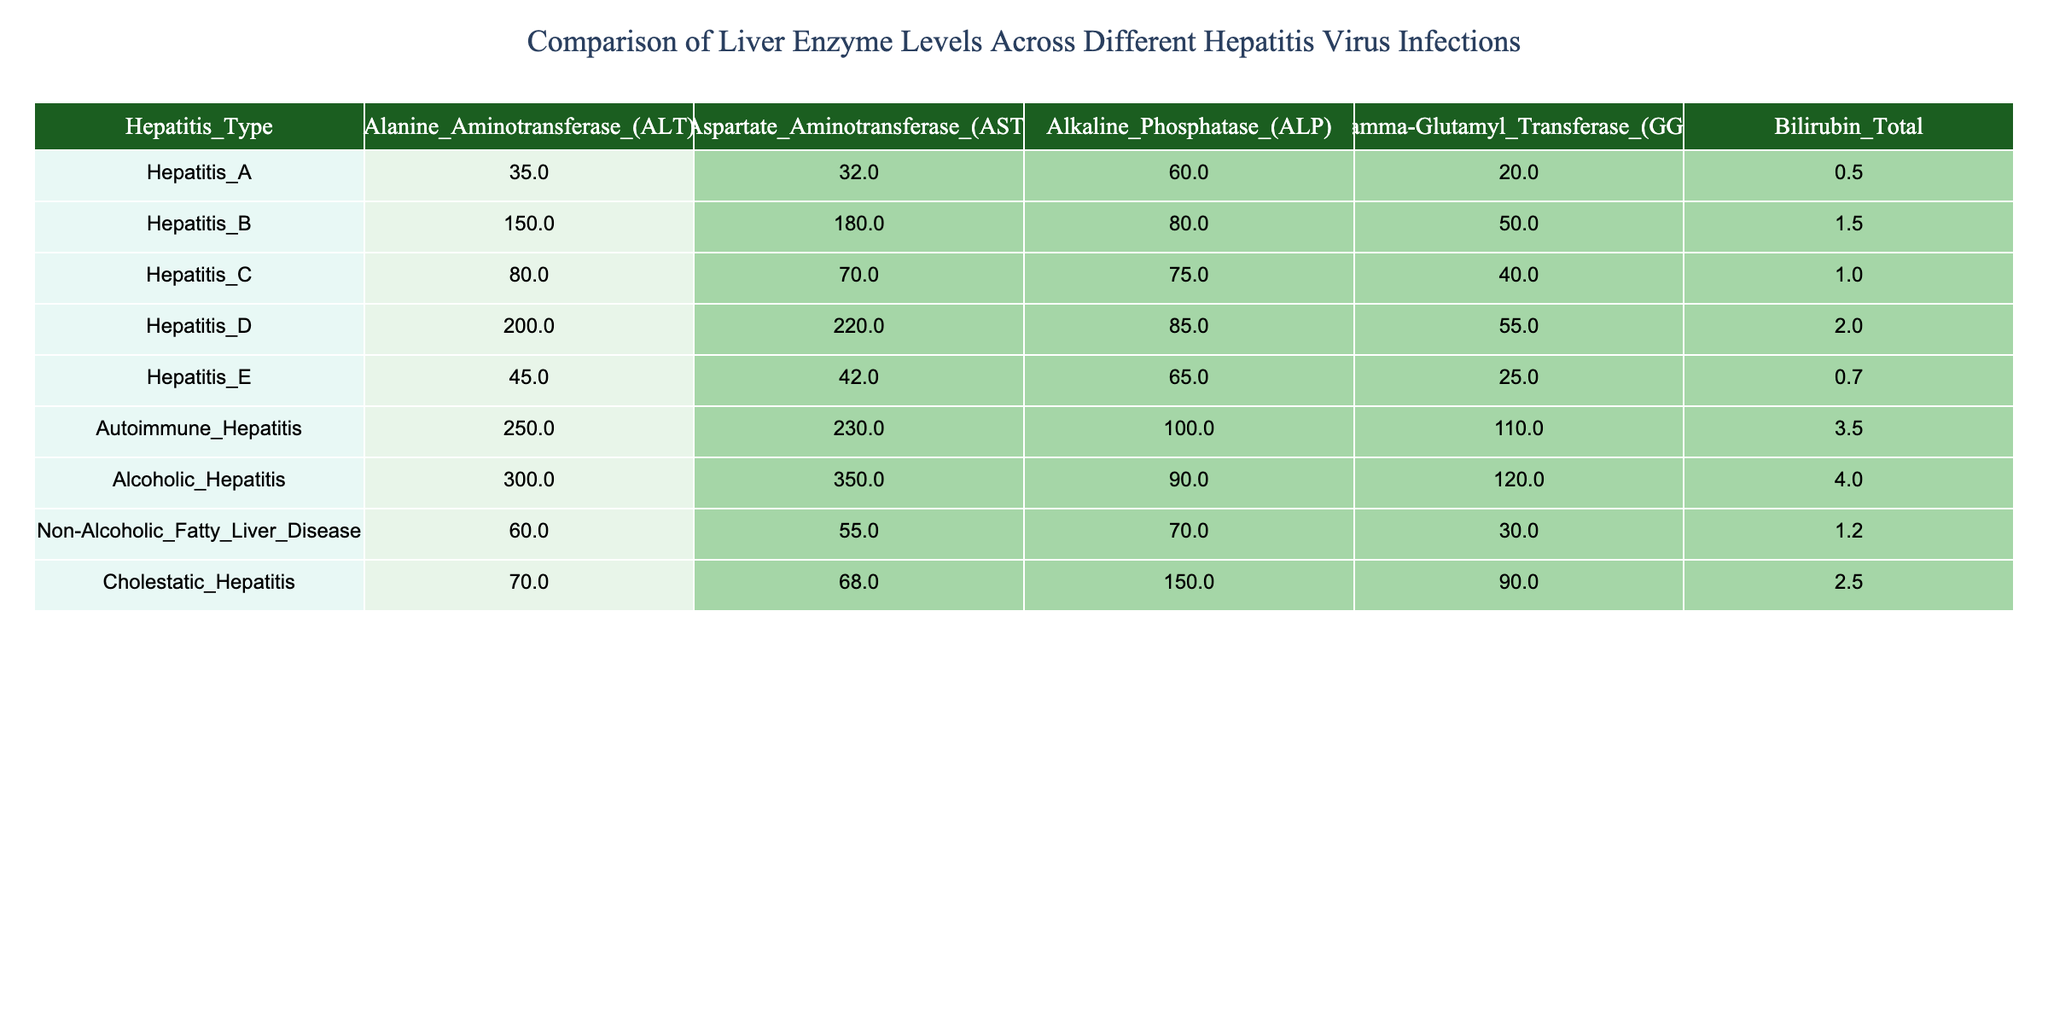What is the ALT level for Autoimmune Hepatitis? The table displays a specific row for Autoimmune Hepatitis where the Alanine Aminotransferase (ALT) level is indicated. Referring to that row, the ALT value is 250.
Answer: 250 Which hepatitis type has the highest AST level? By reviewing the AST levels across all types of hepatitis in the table, the highest AST level is found in Alcoholic Hepatitis, which is 350.
Answer: Alcoholic Hepatitis What is the total bilirubin level for Hepatitis D? The table includes a row for Hepatitis D, where the total bilirubin level is presented. For Hepatitis D, the bilirubin level is 2.0.
Answer: 2.0 Calculate the average GGT level for Hepatitis A, C, and E. The GGT levels for Hepatitis A, C, and E are 20, 40, and 25 respectively. Adding these values gives 85, and dividing by 3 (the number of types) yields an average of approximately 28.33.
Answer: 28.33 Is the ALP level for Cholestatic Hepatitis higher than the average ALP level of the other hepatitis types? The ALP level for Cholestatic Hepatitis is 150. To find out if this is higher, calculate the average ALP for all hepatitis types. The total ALP values are 60 + 80 + 75 + 85 + 65 + 100 + 90 + 70 + 150 = 975, which divided by 9 gives an average of approximately 108.33. Since 150 is greater than 108.33, the statement is true.
Answer: Yes What is the difference between the ALT levels of Autoimmune Hepatitis and Alcoholic Hepatitis? For Autoimmune Hepatitis, the ALT level is 250, and for Alcoholic Hepatitis, it is 300. To find the difference, subtract 250 from 300, resulting in 50.
Answer: 50 Which two hepatitis types have a total bilirubin level below 1.0? Reviewing the table reveals that only Hepatitis A (0.5) and Hepatitis E (0.7) have total bilirubin levels below 1.0. Therefore, these two types can be identified.
Answer: Hepatitis A and Hepatitis E What is the highest alkaline phosphatase level recorded across all hepatitis types? Upon examining the table, the Alkaline Phosphatase (ALP) levels show that the maximum value is present in Autoimmune Hepatitis at 100.
Answer: 100 If we add the ALT levels of Hepatitis B, C, and D, what is the total? The ALT levels for Hepatitis B, C, and D are 150, 80, and 200 respectively. Adding these, 150 + 80 + 200 gives a total of 430.
Answer: 430 Does Hepatitis D have higher enzyme levels across all parameters compared to Hepatitis C? By analyzing the values, for Hepatitis D, the ALT (200), AST (220), ALP (85), and GGT (55) levels need to be compared with Hepatitis C, which has ALT (80), AST (70), ALP (75), and GGT (40). All parameters for Hepatitis D are indeed higher than for Hepatitis C.
Answer: Yes 